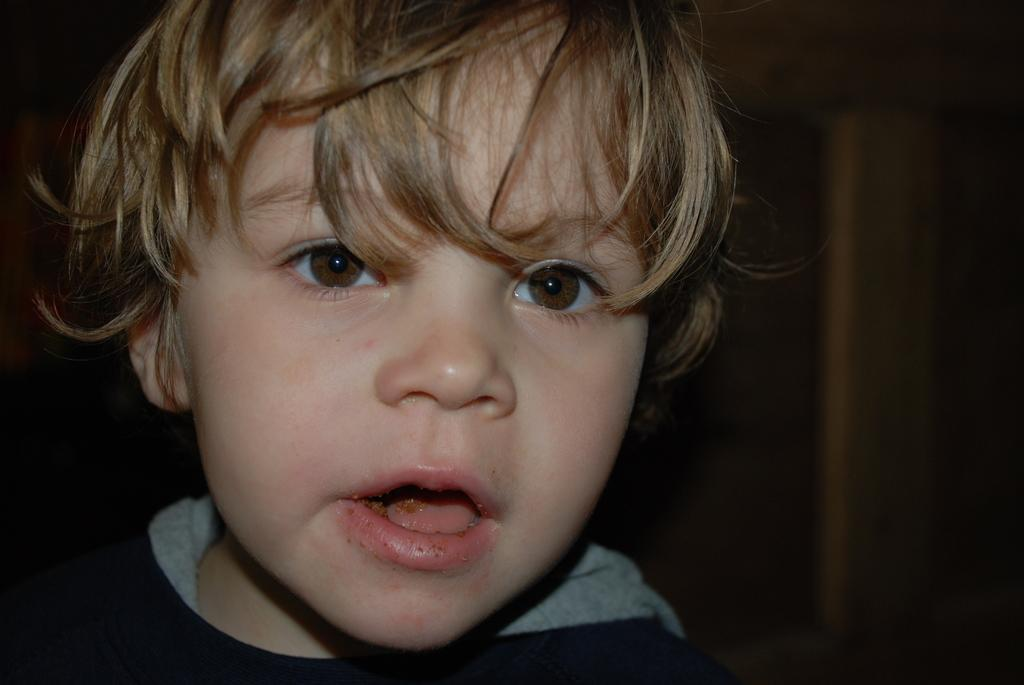What is the main subject of the image? The main subject of the image is a boy. What is the boy doing in the image? The boy is eating a food item in the image. Can you describe the background of the image? The background of the image is dark. What type of hot food is the boy eating in the image? There is no indication of the food being hot in the image, and the specific food item is not mentioned. 